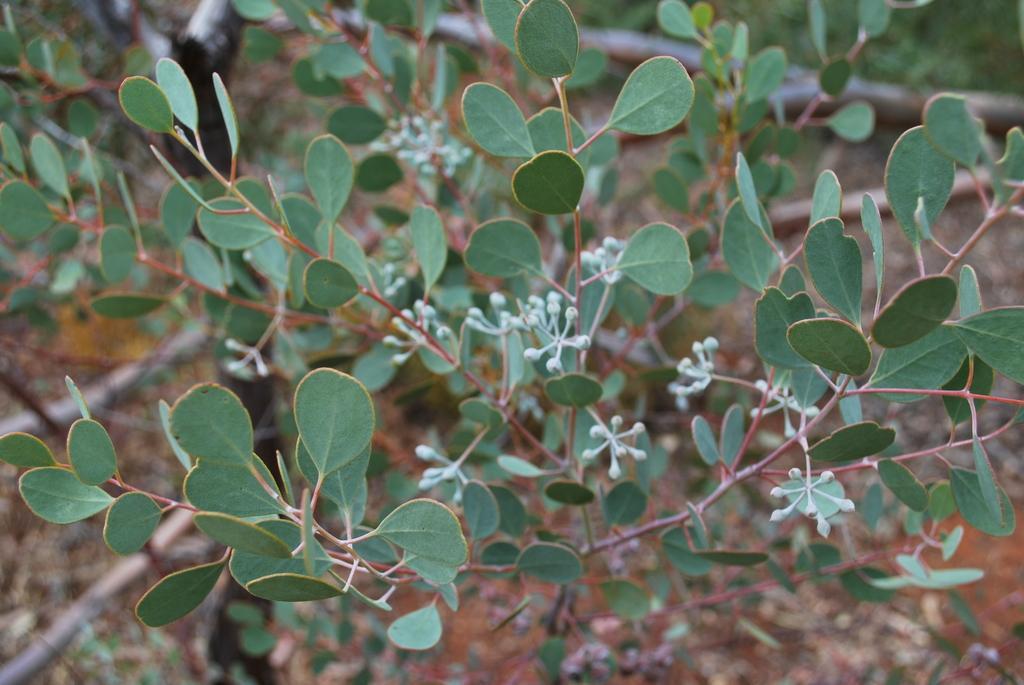How would you summarize this image in a sentence or two? In the image we can see there are plants on the ground. 